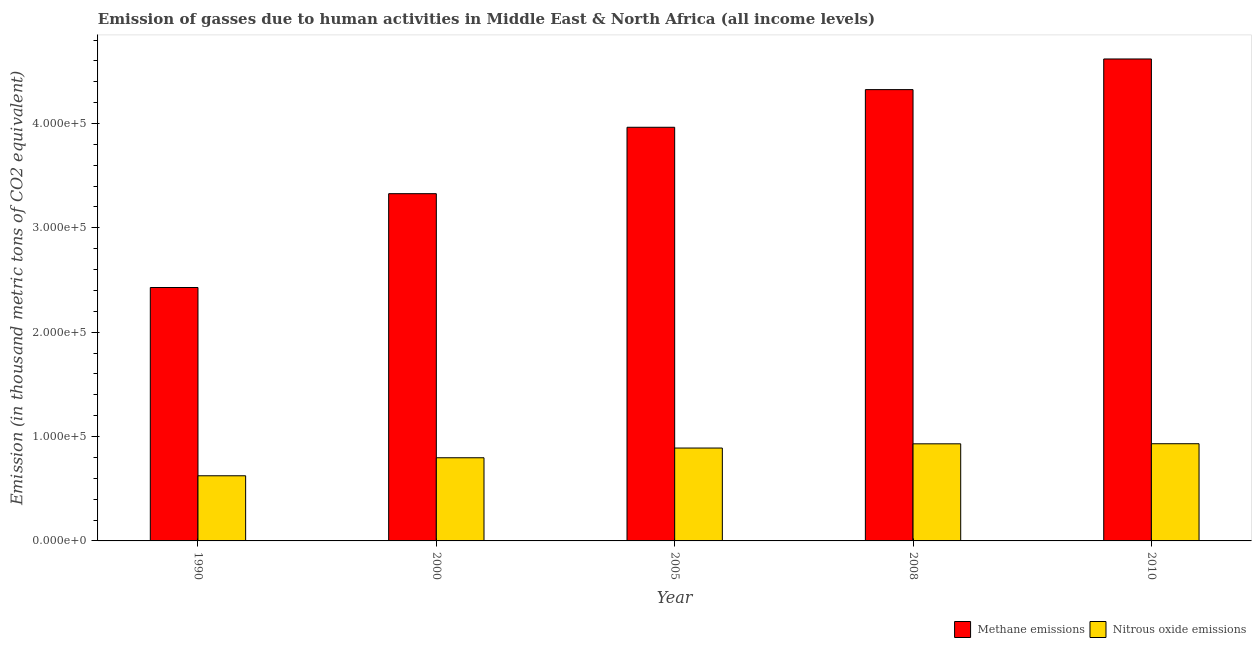Are the number of bars per tick equal to the number of legend labels?
Ensure brevity in your answer.  Yes. How many bars are there on the 4th tick from the right?
Ensure brevity in your answer.  2. What is the amount of methane emissions in 2008?
Provide a succinct answer. 4.32e+05. Across all years, what is the maximum amount of methane emissions?
Give a very brief answer. 4.62e+05. Across all years, what is the minimum amount of nitrous oxide emissions?
Offer a very short reply. 6.24e+04. In which year was the amount of nitrous oxide emissions minimum?
Offer a terse response. 1990. What is the total amount of methane emissions in the graph?
Provide a succinct answer. 1.87e+06. What is the difference between the amount of nitrous oxide emissions in 2005 and that in 2010?
Make the answer very short. -4129.8. What is the difference between the amount of methane emissions in 2000 and the amount of nitrous oxide emissions in 2010?
Offer a terse response. -1.29e+05. What is the average amount of nitrous oxide emissions per year?
Your response must be concise. 8.35e+04. What is the ratio of the amount of nitrous oxide emissions in 1990 to that in 2010?
Provide a succinct answer. 0.67. Is the difference between the amount of nitrous oxide emissions in 2008 and 2010 greater than the difference between the amount of methane emissions in 2008 and 2010?
Your response must be concise. No. What is the difference between the highest and the second highest amount of methane emissions?
Offer a very short reply. 2.94e+04. What is the difference between the highest and the lowest amount of methane emissions?
Ensure brevity in your answer.  2.19e+05. In how many years, is the amount of methane emissions greater than the average amount of methane emissions taken over all years?
Offer a terse response. 3. What does the 2nd bar from the left in 2008 represents?
Make the answer very short. Nitrous oxide emissions. What does the 2nd bar from the right in 2010 represents?
Offer a very short reply. Methane emissions. How many years are there in the graph?
Your answer should be very brief. 5. What is the difference between two consecutive major ticks on the Y-axis?
Your answer should be very brief. 1.00e+05. Are the values on the major ticks of Y-axis written in scientific E-notation?
Your answer should be compact. Yes. Does the graph contain any zero values?
Provide a succinct answer. No. Where does the legend appear in the graph?
Keep it short and to the point. Bottom right. How are the legend labels stacked?
Offer a very short reply. Horizontal. What is the title of the graph?
Your answer should be compact. Emission of gasses due to human activities in Middle East & North Africa (all income levels). Does "Personal remittances" appear as one of the legend labels in the graph?
Keep it short and to the point. No. What is the label or title of the X-axis?
Give a very brief answer. Year. What is the label or title of the Y-axis?
Provide a succinct answer. Emission (in thousand metric tons of CO2 equivalent). What is the Emission (in thousand metric tons of CO2 equivalent) in Methane emissions in 1990?
Make the answer very short. 2.43e+05. What is the Emission (in thousand metric tons of CO2 equivalent) in Nitrous oxide emissions in 1990?
Provide a succinct answer. 6.24e+04. What is the Emission (in thousand metric tons of CO2 equivalent) in Methane emissions in 2000?
Offer a terse response. 3.33e+05. What is the Emission (in thousand metric tons of CO2 equivalent) of Nitrous oxide emissions in 2000?
Offer a very short reply. 7.97e+04. What is the Emission (in thousand metric tons of CO2 equivalent) of Methane emissions in 2005?
Your response must be concise. 3.96e+05. What is the Emission (in thousand metric tons of CO2 equivalent) in Nitrous oxide emissions in 2005?
Ensure brevity in your answer.  8.90e+04. What is the Emission (in thousand metric tons of CO2 equivalent) of Methane emissions in 2008?
Give a very brief answer. 4.32e+05. What is the Emission (in thousand metric tons of CO2 equivalent) of Nitrous oxide emissions in 2008?
Your answer should be compact. 9.30e+04. What is the Emission (in thousand metric tons of CO2 equivalent) of Methane emissions in 2010?
Offer a very short reply. 4.62e+05. What is the Emission (in thousand metric tons of CO2 equivalent) of Nitrous oxide emissions in 2010?
Your response must be concise. 9.31e+04. Across all years, what is the maximum Emission (in thousand metric tons of CO2 equivalent) of Methane emissions?
Your answer should be very brief. 4.62e+05. Across all years, what is the maximum Emission (in thousand metric tons of CO2 equivalent) of Nitrous oxide emissions?
Provide a succinct answer. 9.31e+04. Across all years, what is the minimum Emission (in thousand metric tons of CO2 equivalent) in Methane emissions?
Offer a very short reply. 2.43e+05. Across all years, what is the minimum Emission (in thousand metric tons of CO2 equivalent) in Nitrous oxide emissions?
Give a very brief answer. 6.24e+04. What is the total Emission (in thousand metric tons of CO2 equivalent) of Methane emissions in the graph?
Offer a very short reply. 1.87e+06. What is the total Emission (in thousand metric tons of CO2 equivalent) of Nitrous oxide emissions in the graph?
Offer a terse response. 4.17e+05. What is the difference between the Emission (in thousand metric tons of CO2 equivalent) in Methane emissions in 1990 and that in 2000?
Ensure brevity in your answer.  -8.99e+04. What is the difference between the Emission (in thousand metric tons of CO2 equivalent) in Nitrous oxide emissions in 1990 and that in 2000?
Give a very brief answer. -1.73e+04. What is the difference between the Emission (in thousand metric tons of CO2 equivalent) in Methane emissions in 1990 and that in 2005?
Offer a very short reply. -1.54e+05. What is the difference between the Emission (in thousand metric tons of CO2 equivalent) of Nitrous oxide emissions in 1990 and that in 2005?
Your answer should be very brief. -2.66e+04. What is the difference between the Emission (in thousand metric tons of CO2 equivalent) of Methane emissions in 1990 and that in 2008?
Your answer should be compact. -1.90e+05. What is the difference between the Emission (in thousand metric tons of CO2 equivalent) in Nitrous oxide emissions in 1990 and that in 2008?
Your answer should be very brief. -3.06e+04. What is the difference between the Emission (in thousand metric tons of CO2 equivalent) in Methane emissions in 1990 and that in 2010?
Your response must be concise. -2.19e+05. What is the difference between the Emission (in thousand metric tons of CO2 equivalent) in Nitrous oxide emissions in 1990 and that in 2010?
Provide a succinct answer. -3.07e+04. What is the difference between the Emission (in thousand metric tons of CO2 equivalent) of Methane emissions in 2000 and that in 2005?
Ensure brevity in your answer.  -6.37e+04. What is the difference between the Emission (in thousand metric tons of CO2 equivalent) in Nitrous oxide emissions in 2000 and that in 2005?
Provide a short and direct response. -9317.5. What is the difference between the Emission (in thousand metric tons of CO2 equivalent) in Methane emissions in 2000 and that in 2008?
Your answer should be very brief. -9.97e+04. What is the difference between the Emission (in thousand metric tons of CO2 equivalent) in Nitrous oxide emissions in 2000 and that in 2008?
Make the answer very short. -1.34e+04. What is the difference between the Emission (in thousand metric tons of CO2 equivalent) in Methane emissions in 2000 and that in 2010?
Ensure brevity in your answer.  -1.29e+05. What is the difference between the Emission (in thousand metric tons of CO2 equivalent) in Nitrous oxide emissions in 2000 and that in 2010?
Offer a very short reply. -1.34e+04. What is the difference between the Emission (in thousand metric tons of CO2 equivalent) in Methane emissions in 2005 and that in 2008?
Offer a very short reply. -3.61e+04. What is the difference between the Emission (in thousand metric tons of CO2 equivalent) of Nitrous oxide emissions in 2005 and that in 2008?
Offer a very short reply. -4035.3. What is the difference between the Emission (in thousand metric tons of CO2 equivalent) of Methane emissions in 2005 and that in 2010?
Provide a short and direct response. -6.54e+04. What is the difference between the Emission (in thousand metric tons of CO2 equivalent) in Nitrous oxide emissions in 2005 and that in 2010?
Ensure brevity in your answer.  -4129.8. What is the difference between the Emission (in thousand metric tons of CO2 equivalent) of Methane emissions in 2008 and that in 2010?
Give a very brief answer. -2.94e+04. What is the difference between the Emission (in thousand metric tons of CO2 equivalent) of Nitrous oxide emissions in 2008 and that in 2010?
Your response must be concise. -94.5. What is the difference between the Emission (in thousand metric tons of CO2 equivalent) in Methane emissions in 1990 and the Emission (in thousand metric tons of CO2 equivalent) in Nitrous oxide emissions in 2000?
Offer a very short reply. 1.63e+05. What is the difference between the Emission (in thousand metric tons of CO2 equivalent) of Methane emissions in 1990 and the Emission (in thousand metric tons of CO2 equivalent) of Nitrous oxide emissions in 2005?
Make the answer very short. 1.54e+05. What is the difference between the Emission (in thousand metric tons of CO2 equivalent) of Methane emissions in 1990 and the Emission (in thousand metric tons of CO2 equivalent) of Nitrous oxide emissions in 2008?
Keep it short and to the point. 1.50e+05. What is the difference between the Emission (in thousand metric tons of CO2 equivalent) of Methane emissions in 1990 and the Emission (in thousand metric tons of CO2 equivalent) of Nitrous oxide emissions in 2010?
Give a very brief answer. 1.50e+05. What is the difference between the Emission (in thousand metric tons of CO2 equivalent) in Methane emissions in 2000 and the Emission (in thousand metric tons of CO2 equivalent) in Nitrous oxide emissions in 2005?
Make the answer very short. 2.44e+05. What is the difference between the Emission (in thousand metric tons of CO2 equivalent) of Methane emissions in 2000 and the Emission (in thousand metric tons of CO2 equivalent) of Nitrous oxide emissions in 2008?
Your response must be concise. 2.40e+05. What is the difference between the Emission (in thousand metric tons of CO2 equivalent) of Methane emissions in 2000 and the Emission (in thousand metric tons of CO2 equivalent) of Nitrous oxide emissions in 2010?
Provide a succinct answer. 2.40e+05. What is the difference between the Emission (in thousand metric tons of CO2 equivalent) in Methane emissions in 2005 and the Emission (in thousand metric tons of CO2 equivalent) in Nitrous oxide emissions in 2008?
Offer a very short reply. 3.03e+05. What is the difference between the Emission (in thousand metric tons of CO2 equivalent) of Methane emissions in 2005 and the Emission (in thousand metric tons of CO2 equivalent) of Nitrous oxide emissions in 2010?
Your answer should be compact. 3.03e+05. What is the difference between the Emission (in thousand metric tons of CO2 equivalent) of Methane emissions in 2008 and the Emission (in thousand metric tons of CO2 equivalent) of Nitrous oxide emissions in 2010?
Provide a succinct answer. 3.39e+05. What is the average Emission (in thousand metric tons of CO2 equivalent) in Methane emissions per year?
Keep it short and to the point. 3.73e+05. What is the average Emission (in thousand metric tons of CO2 equivalent) of Nitrous oxide emissions per year?
Provide a succinct answer. 8.35e+04. In the year 1990, what is the difference between the Emission (in thousand metric tons of CO2 equivalent) of Methane emissions and Emission (in thousand metric tons of CO2 equivalent) of Nitrous oxide emissions?
Provide a short and direct response. 1.80e+05. In the year 2000, what is the difference between the Emission (in thousand metric tons of CO2 equivalent) in Methane emissions and Emission (in thousand metric tons of CO2 equivalent) in Nitrous oxide emissions?
Ensure brevity in your answer.  2.53e+05. In the year 2005, what is the difference between the Emission (in thousand metric tons of CO2 equivalent) in Methane emissions and Emission (in thousand metric tons of CO2 equivalent) in Nitrous oxide emissions?
Make the answer very short. 3.07e+05. In the year 2008, what is the difference between the Emission (in thousand metric tons of CO2 equivalent) of Methane emissions and Emission (in thousand metric tons of CO2 equivalent) of Nitrous oxide emissions?
Your answer should be compact. 3.39e+05. In the year 2010, what is the difference between the Emission (in thousand metric tons of CO2 equivalent) of Methane emissions and Emission (in thousand metric tons of CO2 equivalent) of Nitrous oxide emissions?
Provide a succinct answer. 3.69e+05. What is the ratio of the Emission (in thousand metric tons of CO2 equivalent) of Methane emissions in 1990 to that in 2000?
Make the answer very short. 0.73. What is the ratio of the Emission (in thousand metric tons of CO2 equivalent) in Nitrous oxide emissions in 1990 to that in 2000?
Provide a succinct answer. 0.78. What is the ratio of the Emission (in thousand metric tons of CO2 equivalent) of Methane emissions in 1990 to that in 2005?
Offer a terse response. 0.61. What is the ratio of the Emission (in thousand metric tons of CO2 equivalent) of Nitrous oxide emissions in 1990 to that in 2005?
Your answer should be compact. 0.7. What is the ratio of the Emission (in thousand metric tons of CO2 equivalent) of Methane emissions in 1990 to that in 2008?
Offer a very short reply. 0.56. What is the ratio of the Emission (in thousand metric tons of CO2 equivalent) in Nitrous oxide emissions in 1990 to that in 2008?
Provide a succinct answer. 0.67. What is the ratio of the Emission (in thousand metric tons of CO2 equivalent) of Methane emissions in 1990 to that in 2010?
Offer a very short reply. 0.53. What is the ratio of the Emission (in thousand metric tons of CO2 equivalent) of Nitrous oxide emissions in 1990 to that in 2010?
Offer a very short reply. 0.67. What is the ratio of the Emission (in thousand metric tons of CO2 equivalent) of Methane emissions in 2000 to that in 2005?
Your answer should be very brief. 0.84. What is the ratio of the Emission (in thousand metric tons of CO2 equivalent) of Nitrous oxide emissions in 2000 to that in 2005?
Ensure brevity in your answer.  0.9. What is the ratio of the Emission (in thousand metric tons of CO2 equivalent) in Methane emissions in 2000 to that in 2008?
Give a very brief answer. 0.77. What is the ratio of the Emission (in thousand metric tons of CO2 equivalent) in Nitrous oxide emissions in 2000 to that in 2008?
Offer a terse response. 0.86. What is the ratio of the Emission (in thousand metric tons of CO2 equivalent) of Methane emissions in 2000 to that in 2010?
Provide a succinct answer. 0.72. What is the ratio of the Emission (in thousand metric tons of CO2 equivalent) in Nitrous oxide emissions in 2000 to that in 2010?
Your response must be concise. 0.86. What is the ratio of the Emission (in thousand metric tons of CO2 equivalent) in Methane emissions in 2005 to that in 2008?
Your answer should be very brief. 0.92. What is the ratio of the Emission (in thousand metric tons of CO2 equivalent) of Nitrous oxide emissions in 2005 to that in 2008?
Keep it short and to the point. 0.96. What is the ratio of the Emission (in thousand metric tons of CO2 equivalent) in Methane emissions in 2005 to that in 2010?
Provide a short and direct response. 0.86. What is the ratio of the Emission (in thousand metric tons of CO2 equivalent) of Nitrous oxide emissions in 2005 to that in 2010?
Your answer should be compact. 0.96. What is the ratio of the Emission (in thousand metric tons of CO2 equivalent) of Methane emissions in 2008 to that in 2010?
Give a very brief answer. 0.94. What is the difference between the highest and the second highest Emission (in thousand metric tons of CO2 equivalent) in Methane emissions?
Provide a succinct answer. 2.94e+04. What is the difference between the highest and the second highest Emission (in thousand metric tons of CO2 equivalent) in Nitrous oxide emissions?
Offer a terse response. 94.5. What is the difference between the highest and the lowest Emission (in thousand metric tons of CO2 equivalent) in Methane emissions?
Your answer should be very brief. 2.19e+05. What is the difference between the highest and the lowest Emission (in thousand metric tons of CO2 equivalent) in Nitrous oxide emissions?
Your answer should be compact. 3.07e+04. 